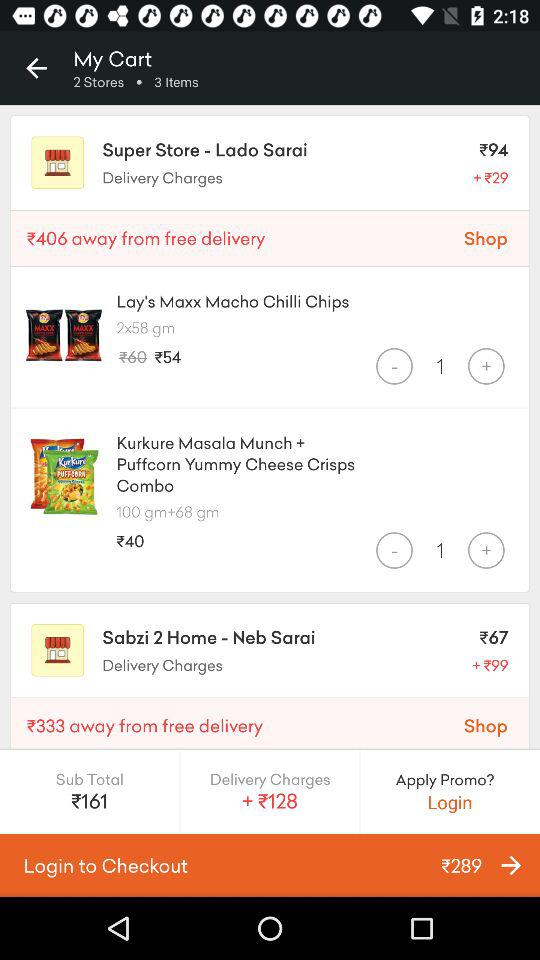From how many stores have the items been ordered? The items have been ordered from 2 stores. 